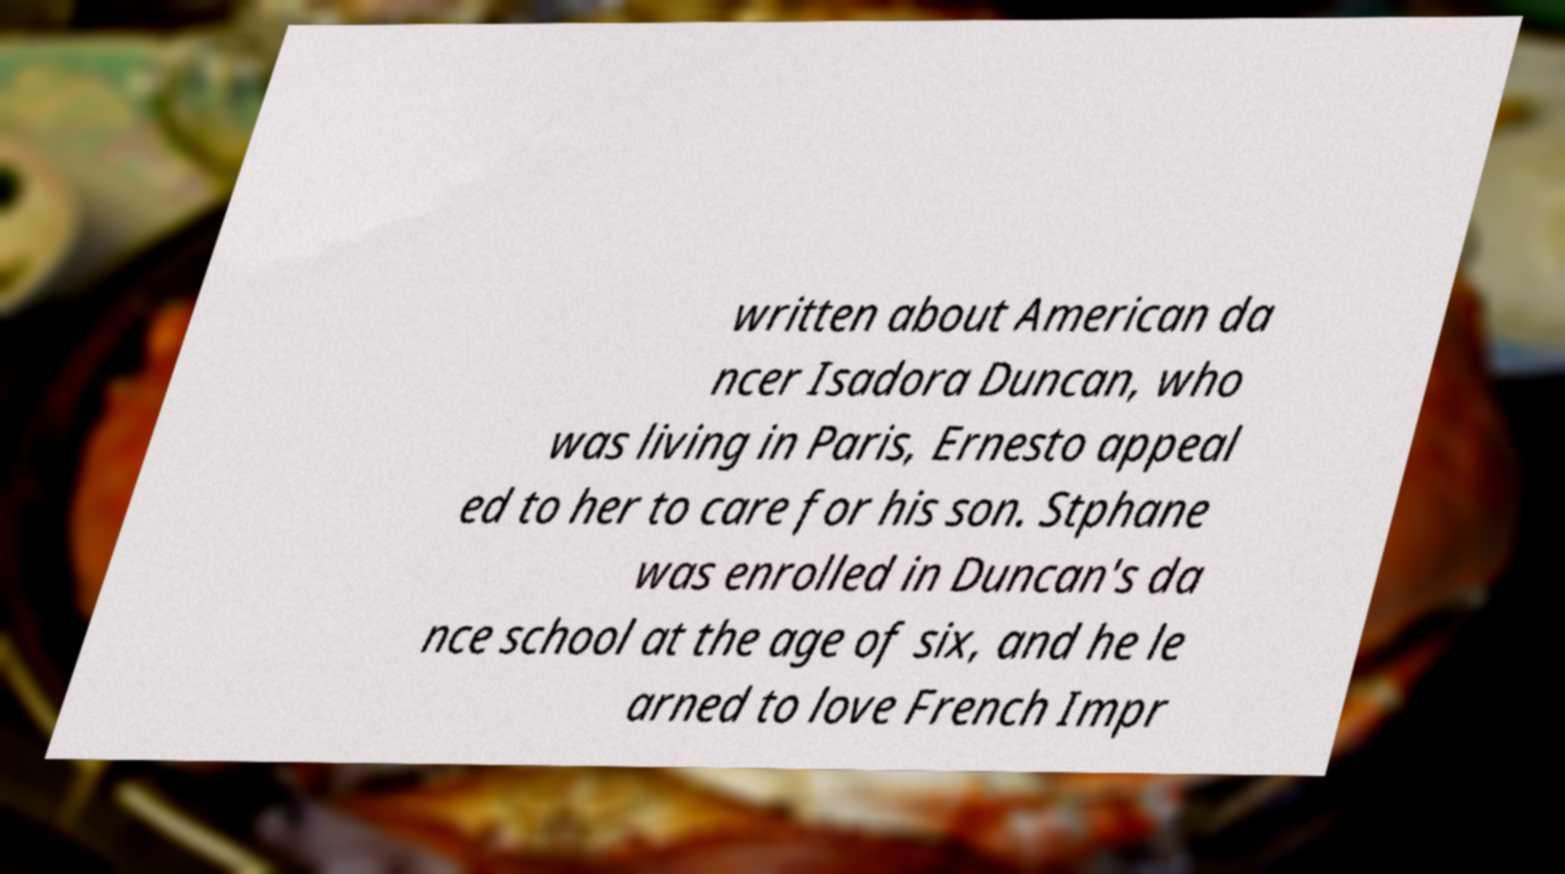There's text embedded in this image that I need extracted. Can you transcribe it verbatim? written about American da ncer Isadora Duncan, who was living in Paris, Ernesto appeal ed to her to care for his son. Stphane was enrolled in Duncan's da nce school at the age of six, and he le arned to love French Impr 